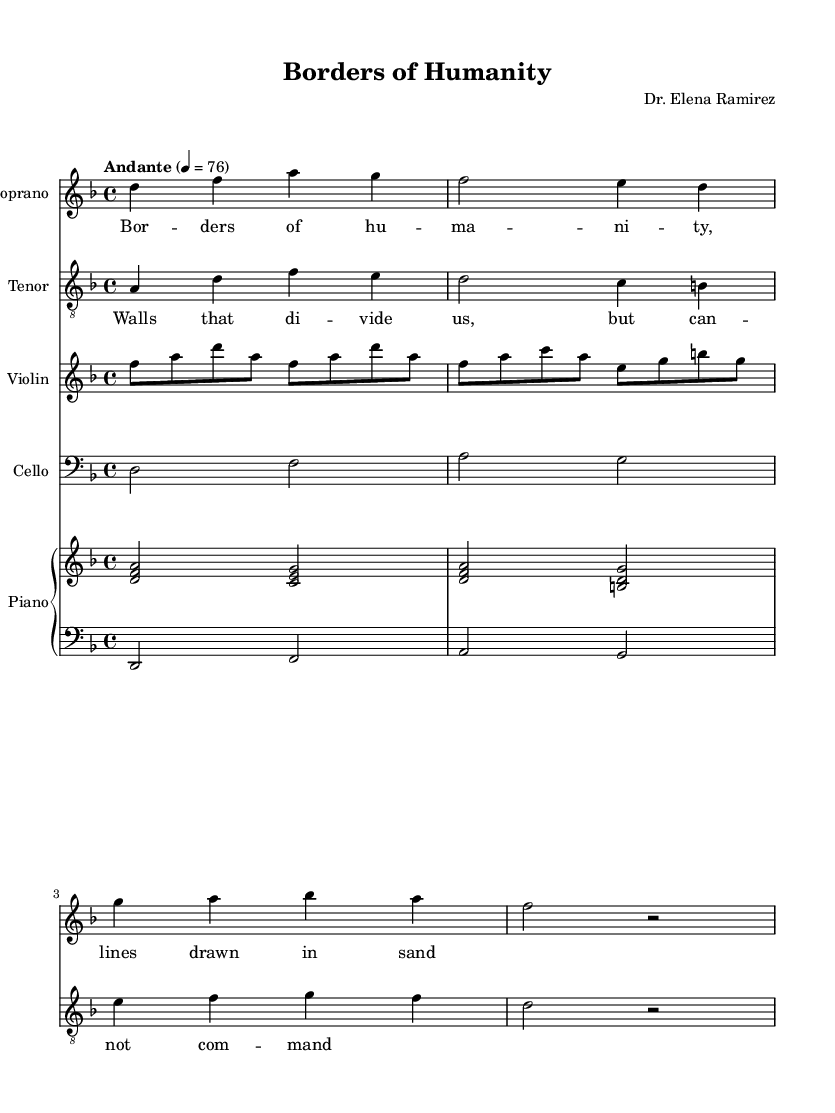What is the key signature of this music? The key signature is denoted by the absence of sharps or flats, which indicates it is in D minor. This is confirmed by the initial instructions in the global section of the music code.
Answer: D minor What is the time signature of this music? The time signature is specified in the code as 4/4, which indicates that there are four beats in each measure and the quarter note receives one beat. This can be seen at the beginning of the global music section.
Answer: 4/4 What is the tempo marking of this piece? The tempo is indicated by "Andante," which is a common term to denote a moderate pace. The numeric part 4 equals 76 shows the beats per minute, confirming this tempo.
Answer: Andante Which instruments are included in this score? The instruments are listed in the score configuration section. They include Soprano, Tenor, Violin, Cello, and Piano. The presence of these instruments forces the specific arrangement of voices and orchestral parts.
Answer: Soprano, Tenor, Violin, Cello, Piano What are the first lyrics sung by the Soprano? The Soprano lyrics "Bor -- ders of hu -- ma -- ni -- ty, lines drawn in sand" are provided directly next to the musical notes designated for the Soprano part. Identifying the lyrics aligns them with their respective melodic line.
Answer: Bor -- ders of hu -- ma -- ni -- ty, lines drawn in sand How many measures are in the Soprano part? The Soprano part consists of four measures, which can be counted from the notation in the music. Each measure is separated by a vertical line, making it easy to quantify.
Answer: 4 What is the last note of the Tenor part? The last note of the Tenor part is denoted by the note D, which appears in the final position of the Tenor section. Inspecting the melody line reveals this conclusion as it is the final note before the end of the segment.
Answer: D 